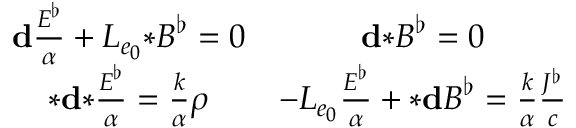Convert formula to latex. <formula><loc_0><loc_0><loc_500><loc_500>\begin{array} { c c } { d \frac { E ^ { \flat } } { \alpha } + L _ { e _ { 0 } } { * } B ^ { \flat } = 0 } & { d { * } B ^ { \flat } = 0 } \\ { { * } d { * } \frac { E ^ { \flat } } { \alpha } = \frac { k } { \alpha } \rho } & { - L _ { e _ { 0 } } \frac { E ^ { \flat } } { \alpha } + { * } d B ^ { \flat } = \frac { k } { \alpha } \frac { J ^ { \flat } } { c } } \end{array}</formula> 